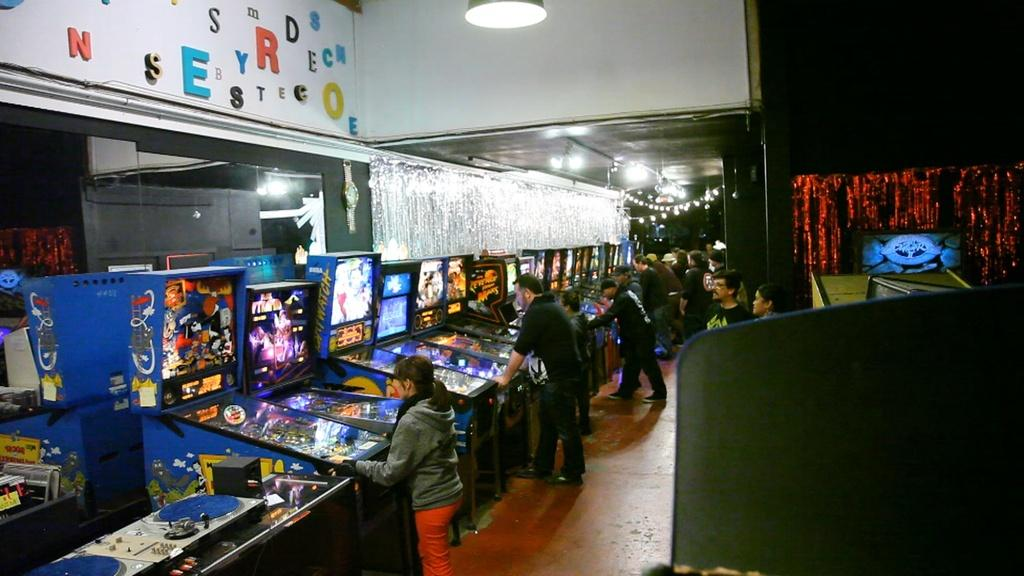What can be seen in the image? There are people standing in the image, along with gaming machines, lights, and other objects. Where are the people standing? The people are standing on the floor in the image. What can be seen above the people in the image? The ceiling is visible in the image. What type of machines are present in the image? Gaming machines are present in the image. What else can be seen in the image besides the people and gaming machines? Lights are visible in the image. What is the tendency of the volleyball in the image? There is no volleyball present in the image, so it is not possible to determine its tendency. 